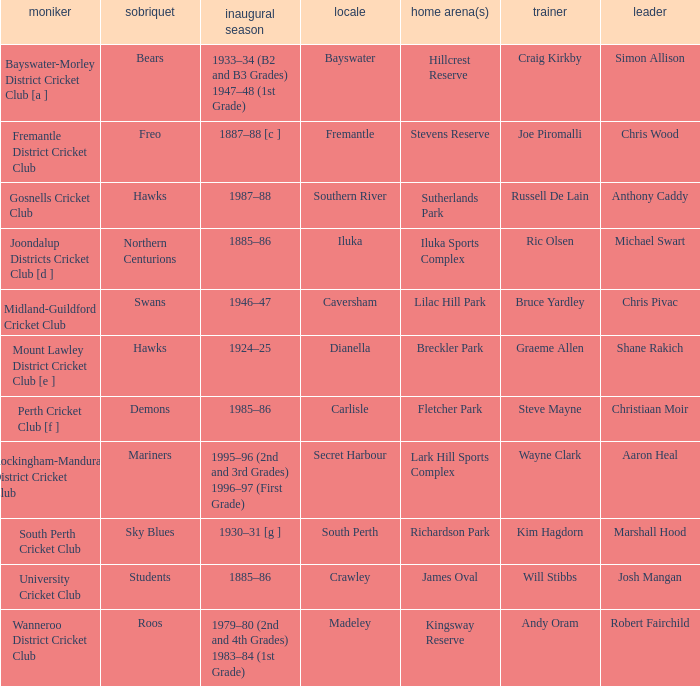What is the location for the club with the nickname the bears? Bayswater. 